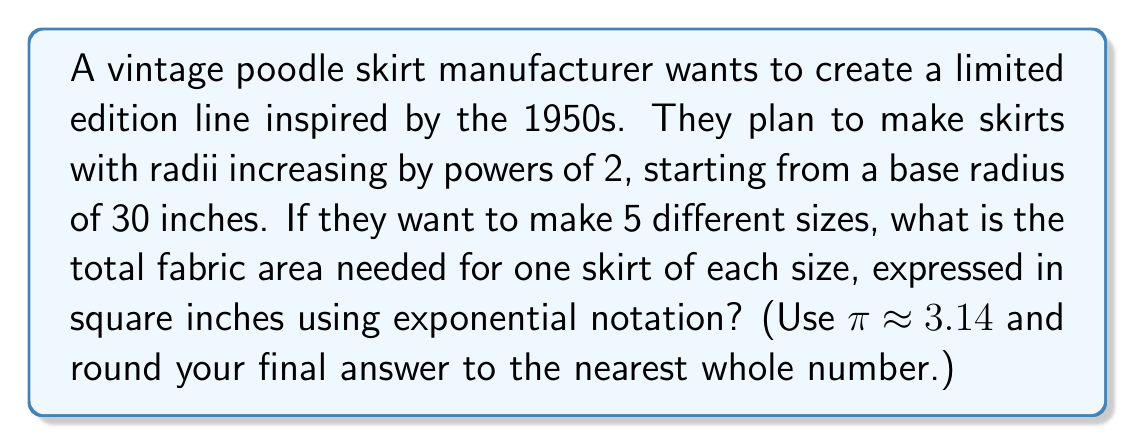Can you solve this math problem? Let's approach this step-by-step:

1) The radii of the skirts form a geometric sequence: 30, 60, 120, 240, and 480 inches.
   We can express this as $30 \cdot 2^n$ where $n = 0, 1, 2, 3, 4$.

2) The area of a circle is given by $A = \pi r^2$.

3) Let's calculate the area for each skirt:

   For $n = 0$: $A_0 = \pi (30)^2 = 2826$ sq in
   For $n = 1$: $A_1 = \pi (60)^2 = 11304$ sq in
   For $n = 2$: $A_2 = \pi (120)^2 = 45216$ sq in
   For $n = 3$: $A_3 = \pi (240)^2 = 180864$ sq in
   For $n = 4$: $A_4 = \pi (480)^2 = 723456$ sq in

4) The total area is the sum of these:
   
   $A_{total} = 2826 + 11304 + 45216 + 180864 + 723456 = 963666$ sq in

5) We can express this in exponential notation:
   
   $963666 \approx 9.64 \times 10^5$ sq in

6) Rounding to the nearest whole number:
   
   $963666 \approx 1 \times 10^6$ sq in
Answer: $1 \times 10^6$ sq in 